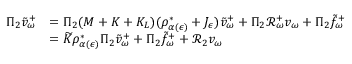Convert formula to latex. <formula><loc_0><loc_0><loc_500><loc_500>\begin{array} { r l } { \Pi _ { 2 } \tilde { v } _ { \omega } ^ { + } } & { = \Pi _ { 2 } ( M + K + K _ { L } ) ( \rho _ { \alpha ( \epsilon ) } ^ { * } + J _ { \epsilon } ) \tilde { v } _ { \omega } ^ { + } + \Pi _ { 2 } \mathcal { R } _ { \omega } ^ { + } v _ { \omega } + \Pi _ { 2 } \tilde { f } _ { \omega } ^ { + } } \\ & { = \widetilde { K } \rho _ { \alpha ( \epsilon ) } ^ { * } \Pi _ { 2 } \tilde { v } _ { \omega } ^ { + } + \Pi _ { 2 } \tilde { f } _ { \omega } ^ { + } + \mathcal { R } _ { 2 } v _ { \omega } } \end{array}</formula> 